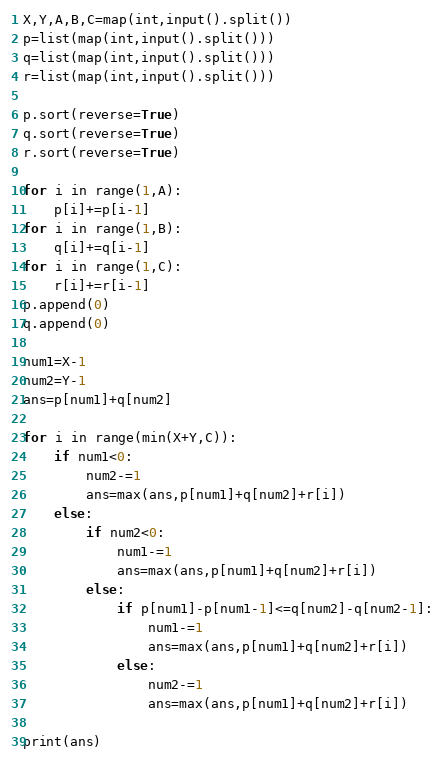Convert code to text. <code><loc_0><loc_0><loc_500><loc_500><_Python_>X,Y,A,B,C=map(int,input().split())
p=list(map(int,input().split()))
q=list(map(int,input().split()))
r=list(map(int,input().split()))

p.sort(reverse=True)
q.sort(reverse=True)
r.sort(reverse=True)

for i in range(1,A):
    p[i]+=p[i-1]
for i in range(1,B):
    q[i]+=q[i-1]
for i in range(1,C):
    r[i]+=r[i-1]
p.append(0)
q.append(0)

num1=X-1
num2=Y-1
ans=p[num1]+q[num2]

for i in range(min(X+Y,C)):
    if num1<0:
        num2-=1
        ans=max(ans,p[num1]+q[num2]+r[i])
    else:
        if num2<0:
            num1-=1
            ans=max(ans,p[num1]+q[num2]+r[i])
        else:
            if p[num1]-p[num1-1]<=q[num2]-q[num2-1]:
                num1-=1
                ans=max(ans,p[num1]+q[num2]+r[i])
            else:
                num2-=1
                ans=max(ans,p[num1]+q[num2]+r[i])
            
print(ans)    </code> 